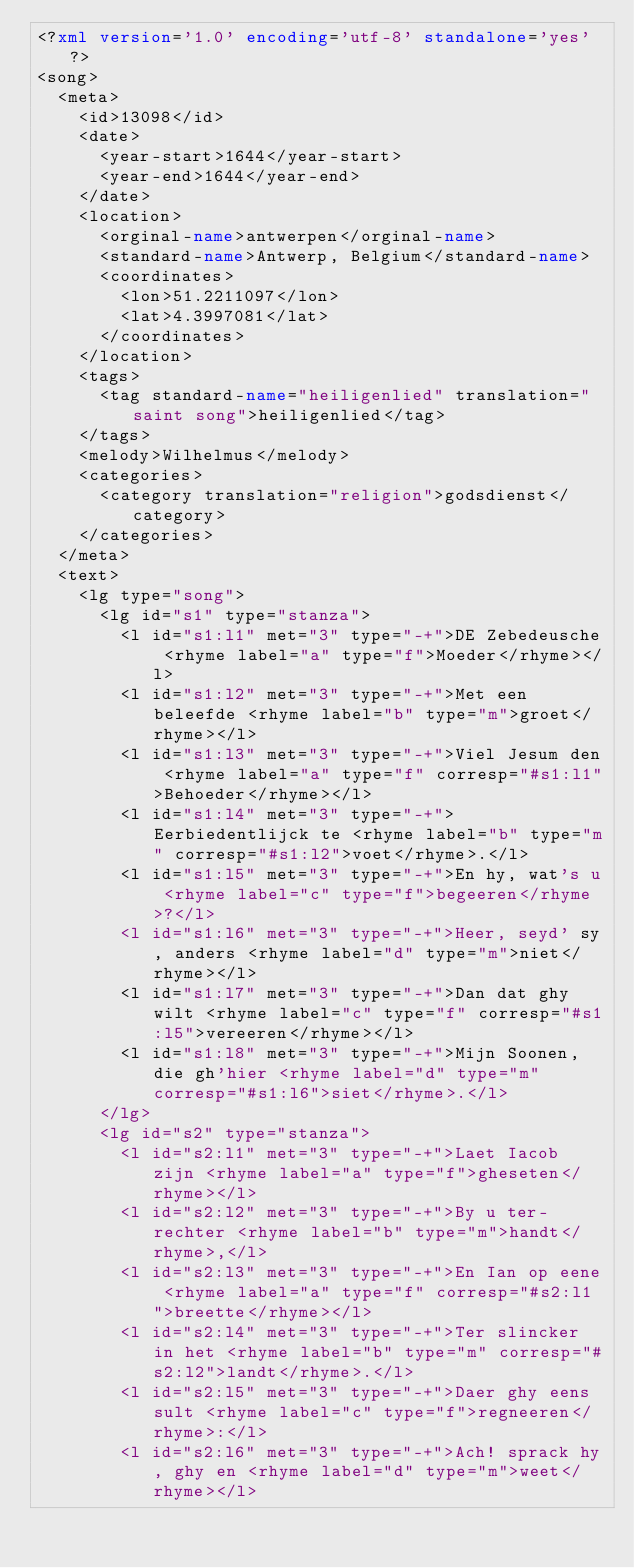Convert code to text. <code><loc_0><loc_0><loc_500><loc_500><_XML_><?xml version='1.0' encoding='utf-8' standalone='yes'?>
<song>
  <meta>
    <id>13098</id>
    <date>
      <year-start>1644</year-start>
      <year-end>1644</year-end>
    </date>
    <location>
      <orginal-name>antwerpen</orginal-name>
      <standard-name>Antwerp, Belgium</standard-name>
      <coordinates>
        <lon>51.2211097</lon>
        <lat>4.3997081</lat>
      </coordinates>
    </location>
    <tags>
      <tag standard-name="heiligenlied" translation="saint song">heiligenlied</tag>
    </tags>
    <melody>Wilhelmus</melody>
    <categories>
      <category translation="religion">godsdienst</category>
    </categories>
  </meta>
  <text>
    <lg type="song">
      <lg id="s1" type="stanza">
        <l id="s1:l1" met="3" type="-+">DE Zebedeusche <rhyme label="a" type="f">Moeder</rhyme></l>
        <l id="s1:l2" met="3" type="-+">Met een beleefde <rhyme label="b" type="m">groet</rhyme></l>
        <l id="s1:l3" met="3" type="-+">Viel Jesum den <rhyme label="a" type="f" corresp="#s1:l1">Behoeder</rhyme></l>
        <l id="s1:l4" met="3" type="-+">Eerbiedentlijck te <rhyme label="b" type="m" corresp="#s1:l2">voet</rhyme>.</l>
        <l id="s1:l5" met="3" type="-+">En hy, wat's u <rhyme label="c" type="f">begeeren</rhyme>?</l>
        <l id="s1:l6" met="3" type="-+">Heer, seyd' sy, anders <rhyme label="d" type="m">niet</rhyme></l>
        <l id="s1:l7" met="3" type="-+">Dan dat ghy wilt <rhyme label="c" type="f" corresp="#s1:l5">vereeren</rhyme></l>
        <l id="s1:l8" met="3" type="-+">Mijn Soonen, die gh'hier <rhyme label="d" type="m" corresp="#s1:l6">siet</rhyme>.</l>
      </lg>
      <lg id="s2" type="stanza">
        <l id="s2:l1" met="3" type="-+">Laet Iacob zijn <rhyme label="a" type="f">gheseten</rhyme></l>
        <l id="s2:l2" met="3" type="-+">By u ter-rechter <rhyme label="b" type="m">handt</rhyme>,</l>
        <l id="s2:l3" met="3" type="-+">En Ian op eene <rhyme label="a" type="f" corresp="#s2:l1">breette</rhyme></l>
        <l id="s2:l4" met="3" type="-+">Ter slincker in het <rhyme label="b" type="m" corresp="#s2:l2">landt</rhyme>.</l>
        <l id="s2:l5" met="3" type="-+">Daer ghy eens sult <rhyme label="c" type="f">regneeren</rhyme>:</l>
        <l id="s2:l6" met="3" type="-+">Ach! sprack hy, ghy en <rhyme label="d" type="m">weet</rhyme></l></code> 